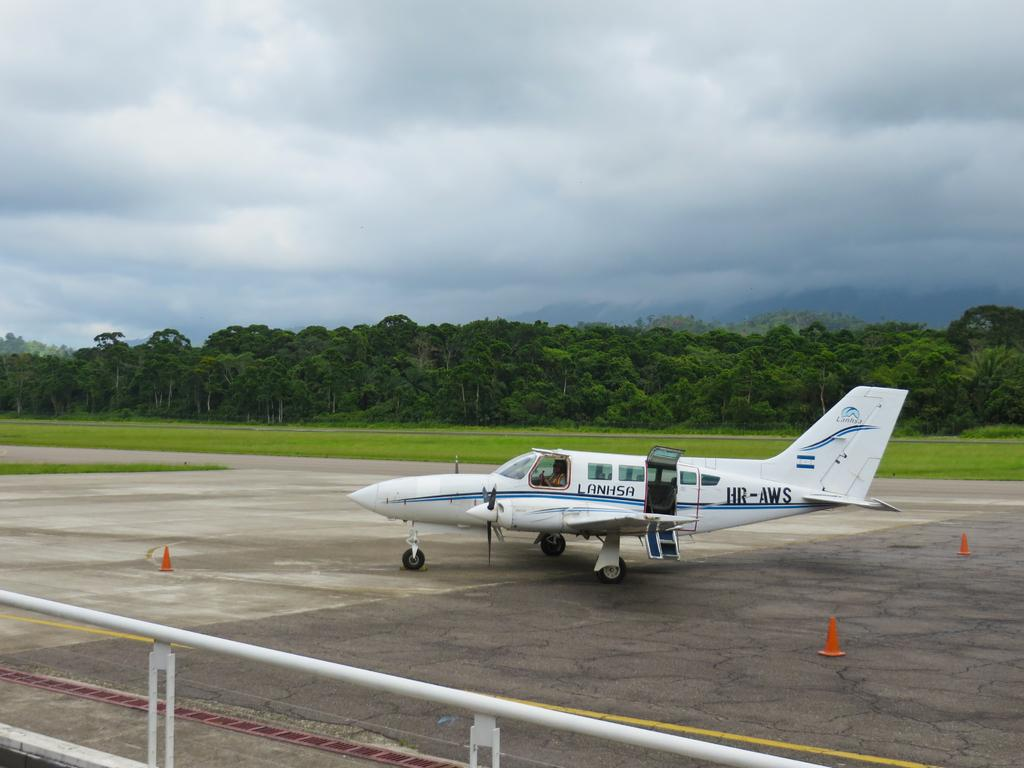<image>
Share a concise interpretation of the image provided. A small passenger plane labeled Lanhsha sits on a runway. 